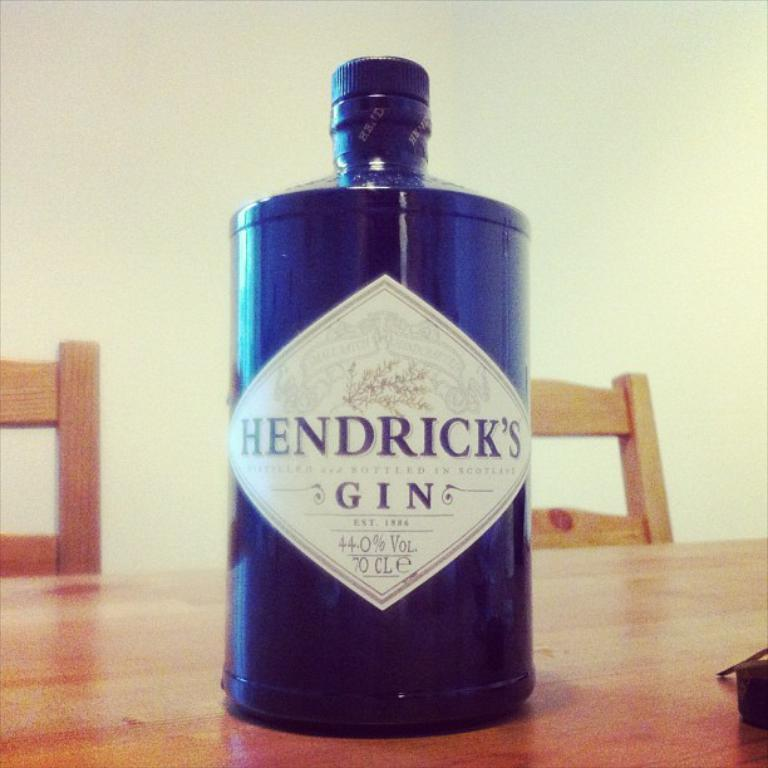<image>
Share a concise interpretation of the image provided. A Hendrick's Gin bottle sitting on a table 